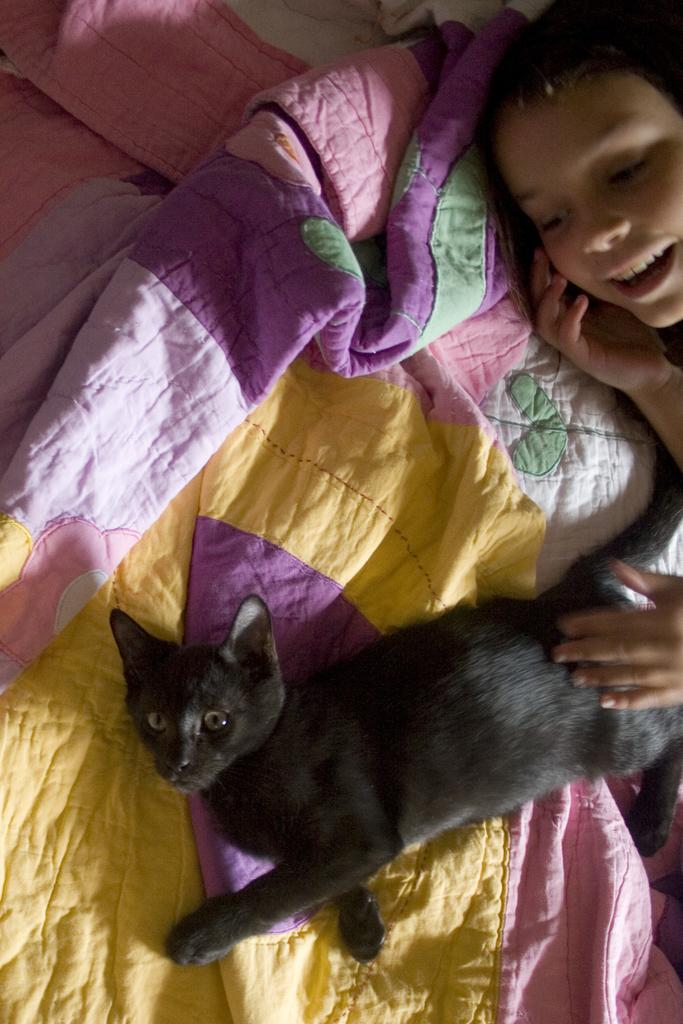Who is present in the image? There is a girl in the image. What is the girl doing in the image? The girl is lying on the bed. Are there any animals in the image? Yes, there is a black cat in the image. What is the black cat doing in the image? The black cat is also lying on the bed. What type of metal can be seen cracking in the image? There is no metal or cracking visible in the image. 